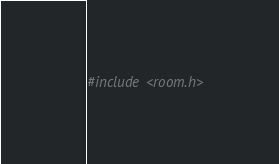<code> <loc_0><loc_0><loc_500><loc_500><_C_>#include <room.h></code> 